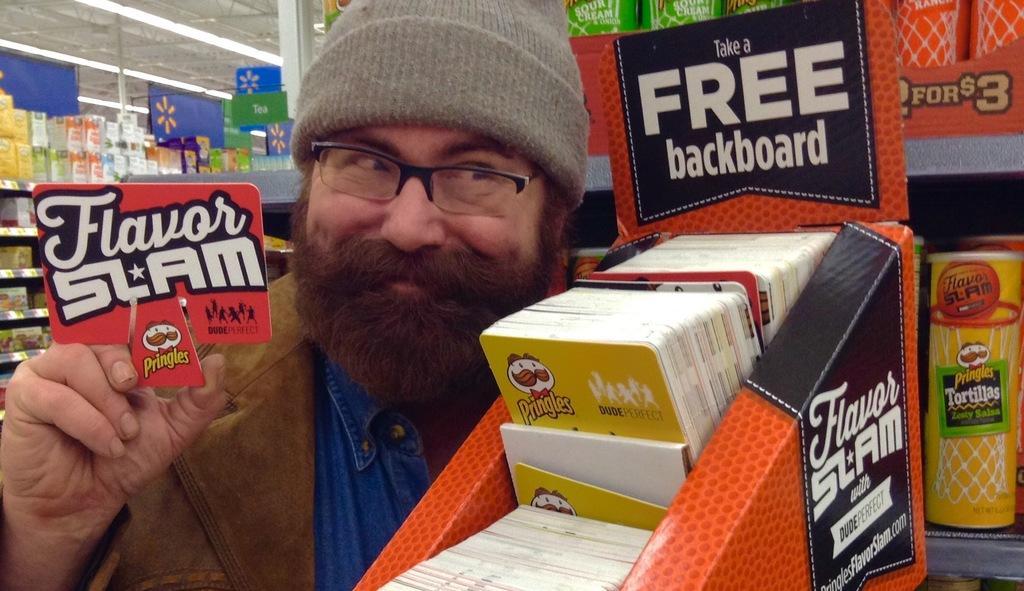In one or two sentences, can you explain what this image depicts? In this image there is a man standing. He is holding a board in his hand. Behind him there are racks. there are objects in the racks. To the right there is text on the boards. At the top there are lights to the ceiling. 